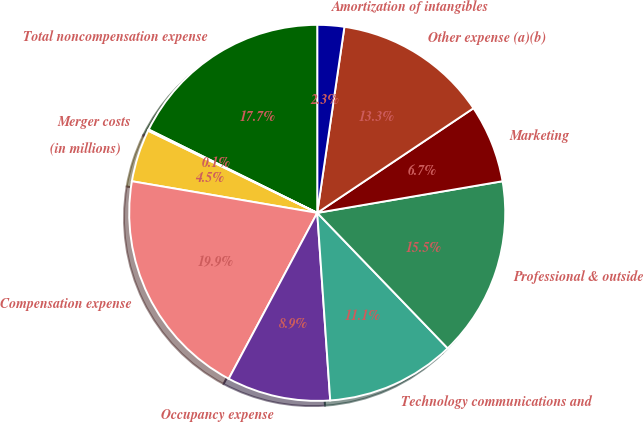<chart> <loc_0><loc_0><loc_500><loc_500><pie_chart><fcel>(in millions)<fcel>Compensation expense<fcel>Occupancy expense<fcel>Technology communications and<fcel>Professional & outside<fcel>Marketing<fcel>Other expense (a)(b)<fcel>Amortization of intangibles<fcel>Total noncompensation expense<fcel>Merger costs<nl><fcel>4.51%<fcel>19.89%<fcel>8.9%<fcel>11.1%<fcel>15.49%<fcel>6.7%<fcel>13.3%<fcel>2.31%<fcel>17.69%<fcel>0.11%<nl></chart> 